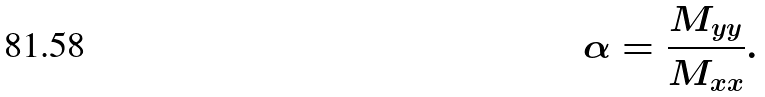<formula> <loc_0><loc_0><loc_500><loc_500>\alpha = \frac { M _ { y y } } { M _ { x x } } .</formula> 